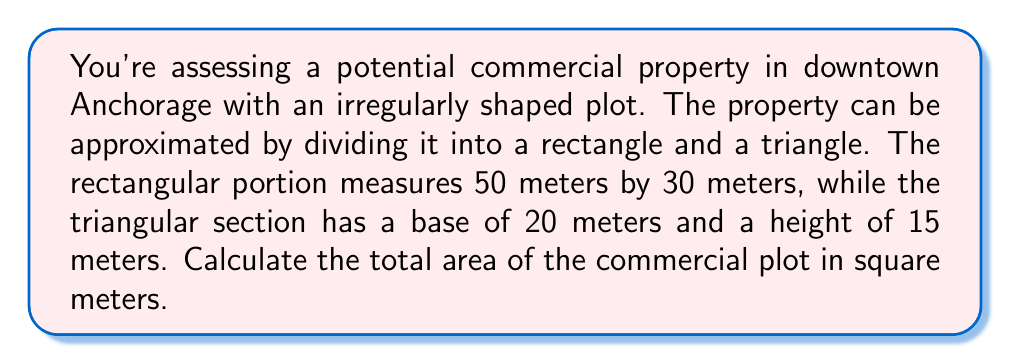Show me your answer to this math problem. To solve this problem, we'll calculate the areas of the rectangle and triangle separately, then add them together.

1. Area of the rectangle:
   $$A_r = l \times w$$
   where $l$ is length and $w$ is width
   $$A_r = 50 \text{ m} \times 30 \text{ m} = 1500 \text{ m}^2$$

2. Area of the triangle:
   $$A_t = \frac{1}{2} \times b \times h$$
   where $b$ is base and $h$ is height
   $$A_t = \frac{1}{2} \times 20 \text{ m} \times 15 \text{ m} = 150 \text{ m}^2$$

3. Total area:
   $$A_{\text{total}} = A_r + A_t$$
   $$A_{\text{total}} = 1500 \text{ m}^2 + 150 \text{ m}^2 = 1650 \text{ m}^2$$

[asy]
unitsize(2mm);
fill((0,0)--(50,0)--(50,30)--(0,30)--cycle,gray(0.9));
fill((50,0)--(70,0)--(50,15)--cycle,gray(0.7));
draw((0,0)--(70,0)--(50,30)--(0,30)--cycle);
draw((50,0)--(50,30));
label("50 m", (25,0), S);
label("30 m", (0,15), W);
label("20 m", (60,0), S);
label("15 m", (55,7.5), E);
[/asy]
Answer: 1650 m² 